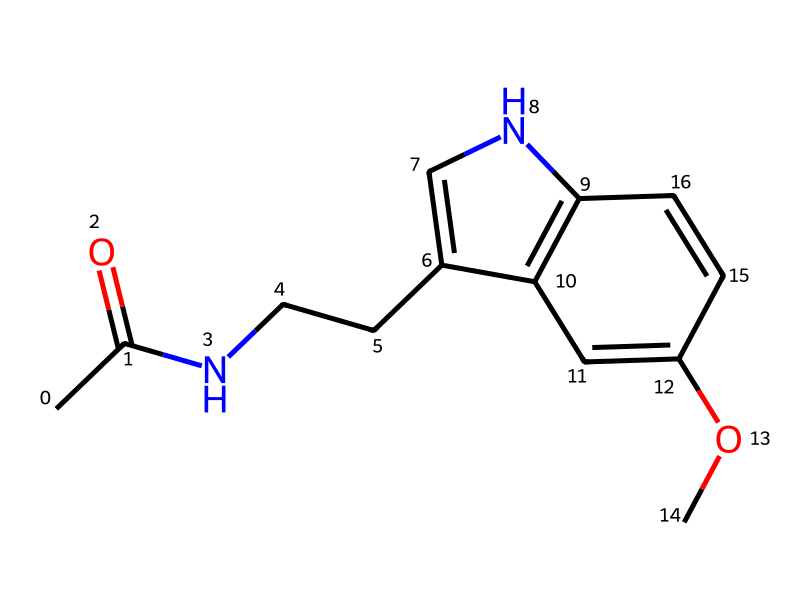What is the total number of carbon atoms in melatonin? By examining the molecular structure represented in the SMILES notation, we can count the carbon (C) atoms. The notation indicates that there are a total of 13 carbon atoms present.
Answer: 13 How many nitrogen atoms are present in this compound? In the given SMILES representation, we can identify nitrogen (N) atoms by counting each occurrence of "N". There are 2 nitrogen atoms in the structure of melatonin.
Answer: 2 Is melatonin an aromatic compound? To determine if melatonin is aromatic, we can look for the presence of conjugated pi electrons in the cyclic structures. The presence of multiple double bonds in a ring structure indicates that it is aromatic, confirming that melatonin is indeed an aromatic compound.
Answer: yes What functional group is present in melatonin? In the structure, we can see that there is an amide group (–C(=O)N–) as part of the molecule, which is distinctive for melatonin. This functional group is indicative of its classification as a medicinal compound.
Answer: amide What is the primary use of melatonin? Melatonin is primarily recognized as a natural sleep aid that helps regulate sleep-wake cycles. This is widely known in both medical and consumer contexts.
Answer: sleep aid Which elements are found in melatonin? By analyzing the chemical formula derived from the SMILES representation, we can find that melatonin consists of carbon, hydrogen, oxygen, and nitrogen atoms, specifically C, H, O, and N.
Answer: carbon, hydrogen, oxygen, nitrogen 